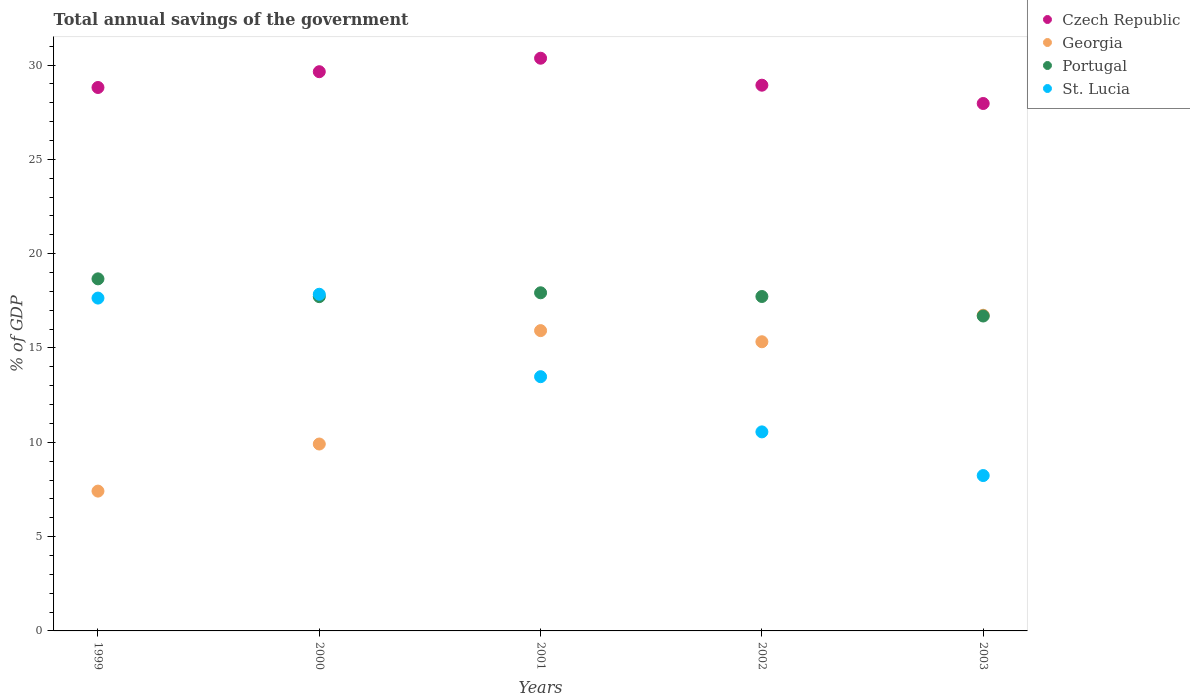Is the number of dotlines equal to the number of legend labels?
Your answer should be very brief. Yes. What is the total annual savings of the government in St. Lucia in 1999?
Your answer should be compact. 17.65. Across all years, what is the maximum total annual savings of the government in Portugal?
Offer a terse response. 18.67. Across all years, what is the minimum total annual savings of the government in St. Lucia?
Provide a short and direct response. 8.24. In which year was the total annual savings of the government in Portugal maximum?
Give a very brief answer. 1999. What is the total total annual savings of the government in St. Lucia in the graph?
Ensure brevity in your answer.  67.76. What is the difference between the total annual savings of the government in Georgia in 2001 and that in 2002?
Give a very brief answer. 0.59. What is the difference between the total annual savings of the government in St. Lucia in 2002 and the total annual savings of the government in Czech Republic in 2003?
Ensure brevity in your answer.  -17.41. What is the average total annual savings of the government in St. Lucia per year?
Ensure brevity in your answer.  13.55. In the year 2003, what is the difference between the total annual savings of the government in St. Lucia and total annual savings of the government in Portugal?
Offer a very short reply. -8.46. What is the ratio of the total annual savings of the government in Georgia in 1999 to that in 2000?
Offer a very short reply. 0.75. Is the total annual savings of the government in Portugal in 2001 less than that in 2002?
Your answer should be compact. No. What is the difference between the highest and the second highest total annual savings of the government in St. Lucia?
Your response must be concise. 0.2. What is the difference between the highest and the lowest total annual savings of the government in St. Lucia?
Offer a very short reply. 9.61. In how many years, is the total annual savings of the government in Portugal greater than the average total annual savings of the government in Portugal taken over all years?
Keep it short and to the point. 2. Is it the case that in every year, the sum of the total annual savings of the government in Portugal and total annual savings of the government in Czech Republic  is greater than the sum of total annual savings of the government in St. Lucia and total annual savings of the government in Georgia?
Provide a short and direct response. Yes. Is it the case that in every year, the sum of the total annual savings of the government in Czech Republic and total annual savings of the government in Portugal  is greater than the total annual savings of the government in St. Lucia?
Provide a succinct answer. Yes. Is the total annual savings of the government in St. Lucia strictly greater than the total annual savings of the government in Portugal over the years?
Ensure brevity in your answer.  No. Is the total annual savings of the government in Czech Republic strictly less than the total annual savings of the government in Portugal over the years?
Keep it short and to the point. No. Does the graph contain grids?
Give a very brief answer. No. What is the title of the graph?
Offer a terse response. Total annual savings of the government. Does "Honduras" appear as one of the legend labels in the graph?
Keep it short and to the point. No. What is the label or title of the Y-axis?
Your response must be concise. % of GDP. What is the % of GDP of Czech Republic in 1999?
Offer a very short reply. 28.81. What is the % of GDP of Georgia in 1999?
Keep it short and to the point. 7.41. What is the % of GDP of Portugal in 1999?
Keep it short and to the point. 18.67. What is the % of GDP of St. Lucia in 1999?
Provide a succinct answer. 17.65. What is the % of GDP of Czech Republic in 2000?
Your answer should be compact. 29.65. What is the % of GDP in Georgia in 2000?
Provide a succinct answer. 9.91. What is the % of GDP in Portugal in 2000?
Your answer should be very brief. 17.72. What is the % of GDP of St. Lucia in 2000?
Offer a terse response. 17.85. What is the % of GDP in Czech Republic in 2001?
Give a very brief answer. 30.36. What is the % of GDP in Georgia in 2001?
Provide a short and direct response. 15.92. What is the % of GDP in Portugal in 2001?
Ensure brevity in your answer.  17.93. What is the % of GDP of St. Lucia in 2001?
Make the answer very short. 13.48. What is the % of GDP in Czech Republic in 2002?
Keep it short and to the point. 28.93. What is the % of GDP of Georgia in 2002?
Keep it short and to the point. 15.33. What is the % of GDP of Portugal in 2002?
Offer a terse response. 17.73. What is the % of GDP in St. Lucia in 2002?
Offer a terse response. 10.55. What is the % of GDP in Czech Republic in 2003?
Give a very brief answer. 27.96. What is the % of GDP of Georgia in 2003?
Provide a short and direct response. 16.74. What is the % of GDP in Portugal in 2003?
Offer a terse response. 16.7. What is the % of GDP of St. Lucia in 2003?
Provide a short and direct response. 8.24. Across all years, what is the maximum % of GDP in Czech Republic?
Make the answer very short. 30.36. Across all years, what is the maximum % of GDP in Georgia?
Provide a short and direct response. 16.74. Across all years, what is the maximum % of GDP of Portugal?
Your response must be concise. 18.67. Across all years, what is the maximum % of GDP of St. Lucia?
Offer a very short reply. 17.85. Across all years, what is the minimum % of GDP in Czech Republic?
Provide a succinct answer. 27.96. Across all years, what is the minimum % of GDP of Georgia?
Make the answer very short. 7.41. Across all years, what is the minimum % of GDP of Portugal?
Keep it short and to the point. 16.7. Across all years, what is the minimum % of GDP of St. Lucia?
Offer a terse response. 8.24. What is the total % of GDP of Czech Republic in the graph?
Your response must be concise. 145.72. What is the total % of GDP of Georgia in the graph?
Make the answer very short. 65.31. What is the total % of GDP of Portugal in the graph?
Offer a very short reply. 88.74. What is the total % of GDP in St. Lucia in the graph?
Your response must be concise. 67.76. What is the difference between the % of GDP in Czech Republic in 1999 and that in 2000?
Your answer should be very brief. -0.84. What is the difference between the % of GDP of Georgia in 1999 and that in 2000?
Your answer should be very brief. -2.5. What is the difference between the % of GDP of Portugal in 1999 and that in 2000?
Your answer should be compact. 0.94. What is the difference between the % of GDP of St. Lucia in 1999 and that in 2000?
Ensure brevity in your answer.  -0.2. What is the difference between the % of GDP in Czech Republic in 1999 and that in 2001?
Your answer should be compact. -1.55. What is the difference between the % of GDP in Georgia in 1999 and that in 2001?
Provide a short and direct response. -8.51. What is the difference between the % of GDP of Portugal in 1999 and that in 2001?
Provide a succinct answer. 0.74. What is the difference between the % of GDP in St. Lucia in 1999 and that in 2001?
Offer a terse response. 4.17. What is the difference between the % of GDP of Czech Republic in 1999 and that in 2002?
Keep it short and to the point. -0.12. What is the difference between the % of GDP of Georgia in 1999 and that in 2002?
Your response must be concise. -7.92. What is the difference between the % of GDP of Portugal in 1999 and that in 2002?
Provide a succinct answer. 0.94. What is the difference between the % of GDP in St. Lucia in 1999 and that in 2002?
Make the answer very short. 7.09. What is the difference between the % of GDP in Czech Republic in 1999 and that in 2003?
Keep it short and to the point. 0.85. What is the difference between the % of GDP in Georgia in 1999 and that in 2003?
Keep it short and to the point. -9.32. What is the difference between the % of GDP in Portugal in 1999 and that in 2003?
Give a very brief answer. 1.97. What is the difference between the % of GDP in St. Lucia in 1999 and that in 2003?
Keep it short and to the point. 9.41. What is the difference between the % of GDP in Czech Republic in 2000 and that in 2001?
Your answer should be very brief. -0.71. What is the difference between the % of GDP of Georgia in 2000 and that in 2001?
Your response must be concise. -6.01. What is the difference between the % of GDP in Portugal in 2000 and that in 2001?
Your answer should be compact. -0.2. What is the difference between the % of GDP in St. Lucia in 2000 and that in 2001?
Provide a short and direct response. 4.37. What is the difference between the % of GDP of Czech Republic in 2000 and that in 2002?
Make the answer very short. 0.72. What is the difference between the % of GDP in Georgia in 2000 and that in 2002?
Your response must be concise. -5.42. What is the difference between the % of GDP in Portugal in 2000 and that in 2002?
Provide a succinct answer. -0.01. What is the difference between the % of GDP in St. Lucia in 2000 and that in 2002?
Your response must be concise. 7.3. What is the difference between the % of GDP in Czech Republic in 2000 and that in 2003?
Make the answer very short. 1.69. What is the difference between the % of GDP of Georgia in 2000 and that in 2003?
Provide a short and direct response. -6.83. What is the difference between the % of GDP of Portugal in 2000 and that in 2003?
Offer a terse response. 1.03. What is the difference between the % of GDP in St. Lucia in 2000 and that in 2003?
Provide a short and direct response. 9.61. What is the difference between the % of GDP of Czech Republic in 2001 and that in 2002?
Offer a very short reply. 1.43. What is the difference between the % of GDP of Georgia in 2001 and that in 2002?
Provide a short and direct response. 0.59. What is the difference between the % of GDP of Portugal in 2001 and that in 2002?
Your answer should be very brief. 0.2. What is the difference between the % of GDP of St. Lucia in 2001 and that in 2002?
Your answer should be compact. 2.93. What is the difference between the % of GDP in Czech Republic in 2001 and that in 2003?
Make the answer very short. 2.4. What is the difference between the % of GDP of Georgia in 2001 and that in 2003?
Your response must be concise. -0.82. What is the difference between the % of GDP of Portugal in 2001 and that in 2003?
Your answer should be very brief. 1.23. What is the difference between the % of GDP of St. Lucia in 2001 and that in 2003?
Provide a short and direct response. 5.24. What is the difference between the % of GDP of Czech Republic in 2002 and that in 2003?
Make the answer very short. 0.97. What is the difference between the % of GDP of Georgia in 2002 and that in 2003?
Provide a short and direct response. -1.41. What is the difference between the % of GDP of Portugal in 2002 and that in 2003?
Make the answer very short. 1.03. What is the difference between the % of GDP of St. Lucia in 2002 and that in 2003?
Ensure brevity in your answer.  2.32. What is the difference between the % of GDP in Czech Republic in 1999 and the % of GDP in Georgia in 2000?
Keep it short and to the point. 18.9. What is the difference between the % of GDP in Czech Republic in 1999 and the % of GDP in Portugal in 2000?
Offer a terse response. 11.09. What is the difference between the % of GDP in Czech Republic in 1999 and the % of GDP in St. Lucia in 2000?
Offer a terse response. 10.96. What is the difference between the % of GDP in Georgia in 1999 and the % of GDP in Portugal in 2000?
Provide a succinct answer. -10.31. What is the difference between the % of GDP in Georgia in 1999 and the % of GDP in St. Lucia in 2000?
Provide a succinct answer. -10.44. What is the difference between the % of GDP of Portugal in 1999 and the % of GDP of St. Lucia in 2000?
Keep it short and to the point. 0.82. What is the difference between the % of GDP of Czech Republic in 1999 and the % of GDP of Georgia in 2001?
Ensure brevity in your answer.  12.89. What is the difference between the % of GDP of Czech Republic in 1999 and the % of GDP of Portugal in 2001?
Give a very brief answer. 10.88. What is the difference between the % of GDP in Czech Republic in 1999 and the % of GDP in St. Lucia in 2001?
Your answer should be very brief. 15.33. What is the difference between the % of GDP in Georgia in 1999 and the % of GDP in Portugal in 2001?
Ensure brevity in your answer.  -10.51. What is the difference between the % of GDP in Georgia in 1999 and the % of GDP in St. Lucia in 2001?
Provide a short and direct response. -6.07. What is the difference between the % of GDP in Portugal in 1999 and the % of GDP in St. Lucia in 2001?
Offer a very short reply. 5.19. What is the difference between the % of GDP in Czech Republic in 1999 and the % of GDP in Georgia in 2002?
Your response must be concise. 13.48. What is the difference between the % of GDP in Czech Republic in 1999 and the % of GDP in Portugal in 2002?
Make the answer very short. 11.08. What is the difference between the % of GDP of Czech Republic in 1999 and the % of GDP of St. Lucia in 2002?
Provide a short and direct response. 18.26. What is the difference between the % of GDP in Georgia in 1999 and the % of GDP in Portugal in 2002?
Provide a short and direct response. -10.32. What is the difference between the % of GDP of Georgia in 1999 and the % of GDP of St. Lucia in 2002?
Offer a terse response. -3.14. What is the difference between the % of GDP of Portugal in 1999 and the % of GDP of St. Lucia in 2002?
Offer a terse response. 8.11. What is the difference between the % of GDP of Czech Republic in 1999 and the % of GDP of Georgia in 2003?
Give a very brief answer. 12.07. What is the difference between the % of GDP in Czech Republic in 1999 and the % of GDP in Portugal in 2003?
Your answer should be compact. 12.12. What is the difference between the % of GDP in Czech Republic in 1999 and the % of GDP in St. Lucia in 2003?
Offer a very short reply. 20.57. What is the difference between the % of GDP of Georgia in 1999 and the % of GDP of Portugal in 2003?
Your response must be concise. -9.28. What is the difference between the % of GDP of Georgia in 1999 and the % of GDP of St. Lucia in 2003?
Offer a terse response. -0.82. What is the difference between the % of GDP of Portugal in 1999 and the % of GDP of St. Lucia in 2003?
Give a very brief answer. 10.43. What is the difference between the % of GDP of Czech Republic in 2000 and the % of GDP of Georgia in 2001?
Provide a short and direct response. 13.73. What is the difference between the % of GDP in Czech Republic in 2000 and the % of GDP in Portugal in 2001?
Your answer should be compact. 11.72. What is the difference between the % of GDP of Czech Republic in 2000 and the % of GDP of St. Lucia in 2001?
Provide a short and direct response. 16.17. What is the difference between the % of GDP of Georgia in 2000 and the % of GDP of Portugal in 2001?
Make the answer very short. -8.02. What is the difference between the % of GDP in Georgia in 2000 and the % of GDP in St. Lucia in 2001?
Provide a succinct answer. -3.57. What is the difference between the % of GDP in Portugal in 2000 and the % of GDP in St. Lucia in 2001?
Your answer should be very brief. 4.24. What is the difference between the % of GDP of Czech Republic in 2000 and the % of GDP of Georgia in 2002?
Give a very brief answer. 14.32. What is the difference between the % of GDP of Czech Republic in 2000 and the % of GDP of Portugal in 2002?
Make the answer very short. 11.92. What is the difference between the % of GDP of Czech Republic in 2000 and the % of GDP of St. Lucia in 2002?
Offer a terse response. 19.1. What is the difference between the % of GDP of Georgia in 2000 and the % of GDP of Portugal in 2002?
Your response must be concise. -7.82. What is the difference between the % of GDP in Georgia in 2000 and the % of GDP in St. Lucia in 2002?
Make the answer very short. -0.64. What is the difference between the % of GDP in Portugal in 2000 and the % of GDP in St. Lucia in 2002?
Offer a very short reply. 7.17. What is the difference between the % of GDP of Czech Republic in 2000 and the % of GDP of Georgia in 2003?
Provide a succinct answer. 12.91. What is the difference between the % of GDP in Czech Republic in 2000 and the % of GDP in Portugal in 2003?
Provide a succinct answer. 12.95. What is the difference between the % of GDP in Czech Republic in 2000 and the % of GDP in St. Lucia in 2003?
Provide a short and direct response. 21.41. What is the difference between the % of GDP of Georgia in 2000 and the % of GDP of Portugal in 2003?
Your response must be concise. -6.79. What is the difference between the % of GDP of Georgia in 2000 and the % of GDP of St. Lucia in 2003?
Your response must be concise. 1.67. What is the difference between the % of GDP of Portugal in 2000 and the % of GDP of St. Lucia in 2003?
Offer a very short reply. 9.49. What is the difference between the % of GDP of Czech Republic in 2001 and the % of GDP of Georgia in 2002?
Your answer should be compact. 15.03. What is the difference between the % of GDP of Czech Republic in 2001 and the % of GDP of Portugal in 2002?
Provide a short and direct response. 12.63. What is the difference between the % of GDP in Czech Republic in 2001 and the % of GDP in St. Lucia in 2002?
Keep it short and to the point. 19.81. What is the difference between the % of GDP of Georgia in 2001 and the % of GDP of Portugal in 2002?
Offer a terse response. -1.81. What is the difference between the % of GDP in Georgia in 2001 and the % of GDP in St. Lucia in 2002?
Keep it short and to the point. 5.37. What is the difference between the % of GDP of Portugal in 2001 and the % of GDP of St. Lucia in 2002?
Your response must be concise. 7.37. What is the difference between the % of GDP of Czech Republic in 2001 and the % of GDP of Georgia in 2003?
Ensure brevity in your answer.  13.63. What is the difference between the % of GDP in Czech Republic in 2001 and the % of GDP in Portugal in 2003?
Keep it short and to the point. 13.67. What is the difference between the % of GDP in Czech Republic in 2001 and the % of GDP in St. Lucia in 2003?
Make the answer very short. 22.13. What is the difference between the % of GDP of Georgia in 2001 and the % of GDP of Portugal in 2003?
Offer a very short reply. -0.77. What is the difference between the % of GDP of Georgia in 2001 and the % of GDP of St. Lucia in 2003?
Keep it short and to the point. 7.68. What is the difference between the % of GDP in Portugal in 2001 and the % of GDP in St. Lucia in 2003?
Provide a short and direct response. 9.69. What is the difference between the % of GDP in Czech Republic in 2002 and the % of GDP in Georgia in 2003?
Your answer should be compact. 12.2. What is the difference between the % of GDP in Czech Republic in 2002 and the % of GDP in Portugal in 2003?
Provide a succinct answer. 12.24. What is the difference between the % of GDP of Czech Republic in 2002 and the % of GDP of St. Lucia in 2003?
Give a very brief answer. 20.7. What is the difference between the % of GDP of Georgia in 2002 and the % of GDP of Portugal in 2003?
Your response must be concise. -1.36. What is the difference between the % of GDP of Georgia in 2002 and the % of GDP of St. Lucia in 2003?
Offer a terse response. 7.09. What is the difference between the % of GDP in Portugal in 2002 and the % of GDP in St. Lucia in 2003?
Provide a succinct answer. 9.49. What is the average % of GDP in Czech Republic per year?
Your answer should be very brief. 29.14. What is the average % of GDP in Georgia per year?
Keep it short and to the point. 13.06. What is the average % of GDP in Portugal per year?
Provide a succinct answer. 17.75. What is the average % of GDP of St. Lucia per year?
Your answer should be compact. 13.55. In the year 1999, what is the difference between the % of GDP in Czech Republic and % of GDP in Georgia?
Offer a very short reply. 21.4. In the year 1999, what is the difference between the % of GDP in Czech Republic and % of GDP in Portugal?
Make the answer very short. 10.15. In the year 1999, what is the difference between the % of GDP of Czech Republic and % of GDP of St. Lucia?
Your answer should be compact. 11.16. In the year 1999, what is the difference between the % of GDP in Georgia and % of GDP in Portugal?
Give a very brief answer. -11.25. In the year 1999, what is the difference between the % of GDP in Georgia and % of GDP in St. Lucia?
Keep it short and to the point. -10.23. In the year 1999, what is the difference between the % of GDP in Portugal and % of GDP in St. Lucia?
Offer a terse response. 1.02. In the year 2000, what is the difference between the % of GDP of Czech Republic and % of GDP of Georgia?
Your response must be concise. 19.74. In the year 2000, what is the difference between the % of GDP in Czech Republic and % of GDP in Portugal?
Your answer should be compact. 11.93. In the year 2000, what is the difference between the % of GDP in Czech Republic and % of GDP in St. Lucia?
Keep it short and to the point. 11.8. In the year 2000, what is the difference between the % of GDP in Georgia and % of GDP in Portugal?
Provide a short and direct response. -7.81. In the year 2000, what is the difference between the % of GDP in Georgia and % of GDP in St. Lucia?
Offer a very short reply. -7.94. In the year 2000, what is the difference between the % of GDP of Portugal and % of GDP of St. Lucia?
Give a very brief answer. -0.13. In the year 2001, what is the difference between the % of GDP in Czech Republic and % of GDP in Georgia?
Keep it short and to the point. 14.44. In the year 2001, what is the difference between the % of GDP of Czech Republic and % of GDP of Portugal?
Your response must be concise. 12.44. In the year 2001, what is the difference between the % of GDP of Czech Republic and % of GDP of St. Lucia?
Keep it short and to the point. 16.88. In the year 2001, what is the difference between the % of GDP in Georgia and % of GDP in Portugal?
Your answer should be compact. -2.01. In the year 2001, what is the difference between the % of GDP in Georgia and % of GDP in St. Lucia?
Your response must be concise. 2.44. In the year 2001, what is the difference between the % of GDP in Portugal and % of GDP in St. Lucia?
Offer a terse response. 4.45. In the year 2002, what is the difference between the % of GDP of Czech Republic and % of GDP of Georgia?
Your answer should be very brief. 13.6. In the year 2002, what is the difference between the % of GDP of Czech Republic and % of GDP of Portugal?
Keep it short and to the point. 11.2. In the year 2002, what is the difference between the % of GDP of Czech Republic and % of GDP of St. Lucia?
Give a very brief answer. 18.38. In the year 2002, what is the difference between the % of GDP in Georgia and % of GDP in Portugal?
Offer a terse response. -2.4. In the year 2002, what is the difference between the % of GDP in Georgia and % of GDP in St. Lucia?
Your answer should be compact. 4.78. In the year 2002, what is the difference between the % of GDP in Portugal and % of GDP in St. Lucia?
Make the answer very short. 7.18. In the year 2003, what is the difference between the % of GDP of Czech Republic and % of GDP of Georgia?
Keep it short and to the point. 11.23. In the year 2003, what is the difference between the % of GDP in Czech Republic and % of GDP in Portugal?
Your answer should be very brief. 11.27. In the year 2003, what is the difference between the % of GDP in Czech Republic and % of GDP in St. Lucia?
Make the answer very short. 19.73. In the year 2003, what is the difference between the % of GDP of Georgia and % of GDP of Portugal?
Provide a succinct answer. 0.04. In the year 2003, what is the difference between the % of GDP of Georgia and % of GDP of St. Lucia?
Ensure brevity in your answer.  8.5. In the year 2003, what is the difference between the % of GDP in Portugal and % of GDP in St. Lucia?
Offer a very short reply. 8.46. What is the ratio of the % of GDP in Czech Republic in 1999 to that in 2000?
Make the answer very short. 0.97. What is the ratio of the % of GDP of Georgia in 1999 to that in 2000?
Give a very brief answer. 0.75. What is the ratio of the % of GDP of Portugal in 1999 to that in 2000?
Your answer should be very brief. 1.05. What is the ratio of the % of GDP of St. Lucia in 1999 to that in 2000?
Make the answer very short. 0.99. What is the ratio of the % of GDP in Czech Republic in 1999 to that in 2001?
Provide a short and direct response. 0.95. What is the ratio of the % of GDP of Georgia in 1999 to that in 2001?
Offer a terse response. 0.47. What is the ratio of the % of GDP in Portugal in 1999 to that in 2001?
Provide a short and direct response. 1.04. What is the ratio of the % of GDP in St. Lucia in 1999 to that in 2001?
Keep it short and to the point. 1.31. What is the ratio of the % of GDP in Georgia in 1999 to that in 2002?
Your response must be concise. 0.48. What is the ratio of the % of GDP in Portugal in 1999 to that in 2002?
Ensure brevity in your answer.  1.05. What is the ratio of the % of GDP of St. Lucia in 1999 to that in 2002?
Ensure brevity in your answer.  1.67. What is the ratio of the % of GDP in Czech Republic in 1999 to that in 2003?
Offer a terse response. 1.03. What is the ratio of the % of GDP of Georgia in 1999 to that in 2003?
Keep it short and to the point. 0.44. What is the ratio of the % of GDP in Portugal in 1999 to that in 2003?
Your answer should be very brief. 1.12. What is the ratio of the % of GDP of St. Lucia in 1999 to that in 2003?
Ensure brevity in your answer.  2.14. What is the ratio of the % of GDP of Czech Republic in 2000 to that in 2001?
Your answer should be compact. 0.98. What is the ratio of the % of GDP in Georgia in 2000 to that in 2001?
Your answer should be compact. 0.62. What is the ratio of the % of GDP of Portugal in 2000 to that in 2001?
Offer a terse response. 0.99. What is the ratio of the % of GDP of St. Lucia in 2000 to that in 2001?
Make the answer very short. 1.32. What is the ratio of the % of GDP in Czech Republic in 2000 to that in 2002?
Provide a succinct answer. 1.02. What is the ratio of the % of GDP of Georgia in 2000 to that in 2002?
Provide a succinct answer. 0.65. What is the ratio of the % of GDP of St. Lucia in 2000 to that in 2002?
Make the answer very short. 1.69. What is the ratio of the % of GDP of Czech Republic in 2000 to that in 2003?
Give a very brief answer. 1.06. What is the ratio of the % of GDP of Georgia in 2000 to that in 2003?
Your answer should be very brief. 0.59. What is the ratio of the % of GDP in Portugal in 2000 to that in 2003?
Keep it short and to the point. 1.06. What is the ratio of the % of GDP of St. Lucia in 2000 to that in 2003?
Make the answer very short. 2.17. What is the ratio of the % of GDP of Czech Republic in 2001 to that in 2002?
Your answer should be very brief. 1.05. What is the ratio of the % of GDP in Portugal in 2001 to that in 2002?
Your answer should be very brief. 1.01. What is the ratio of the % of GDP in St. Lucia in 2001 to that in 2002?
Ensure brevity in your answer.  1.28. What is the ratio of the % of GDP of Czech Republic in 2001 to that in 2003?
Your answer should be compact. 1.09. What is the ratio of the % of GDP in Georgia in 2001 to that in 2003?
Offer a terse response. 0.95. What is the ratio of the % of GDP in Portugal in 2001 to that in 2003?
Keep it short and to the point. 1.07. What is the ratio of the % of GDP of St. Lucia in 2001 to that in 2003?
Offer a very short reply. 1.64. What is the ratio of the % of GDP of Czech Republic in 2002 to that in 2003?
Your answer should be compact. 1.03. What is the ratio of the % of GDP of Georgia in 2002 to that in 2003?
Make the answer very short. 0.92. What is the ratio of the % of GDP in Portugal in 2002 to that in 2003?
Provide a succinct answer. 1.06. What is the ratio of the % of GDP of St. Lucia in 2002 to that in 2003?
Offer a terse response. 1.28. What is the difference between the highest and the second highest % of GDP in Czech Republic?
Make the answer very short. 0.71. What is the difference between the highest and the second highest % of GDP of Georgia?
Make the answer very short. 0.82. What is the difference between the highest and the second highest % of GDP of Portugal?
Offer a very short reply. 0.74. What is the difference between the highest and the second highest % of GDP of St. Lucia?
Your response must be concise. 0.2. What is the difference between the highest and the lowest % of GDP in Czech Republic?
Your answer should be very brief. 2.4. What is the difference between the highest and the lowest % of GDP in Georgia?
Your answer should be very brief. 9.32. What is the difference between the highest and the lowest % of GDP of Portugal?
Make the answer very short. 1.97. What is the difference between the highest and the lowest % of GDP in St. Lucia?
Your answer should be very brief. 9.61. 